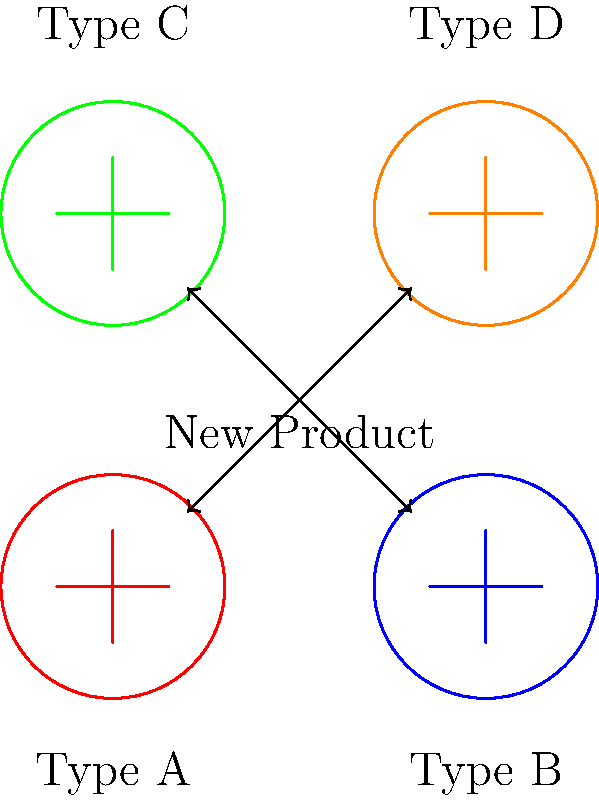You want to use a simple system to categorize your products into different types. Looking at the image, which shows example products of different types and a new product to be categorized, how would you describe the process of determining the type for the new product? To categorize a new product into one of the existing types, follow these steps:

1. Look at the example products for each type (A, B, C, and D).
2. Compare the new product's features or appearance to the examples.
3. Find the example that most closely matches the new product.
4. Assign the type of the matching example to the new product.

This process is similar to how basic image classification works in machine learning:

1. The system is shown example images for each category (training data).
2. When a new image is presented, the system compares it to the examples it has learned.
3. The system assigns the new image to the category it most closely resembles.

In this simplified version, you're doing the comparison manually, but the principle is the same as what a computer would do automatically in a more advanced system.
Answer: Compare new product to examples and assign matching type 